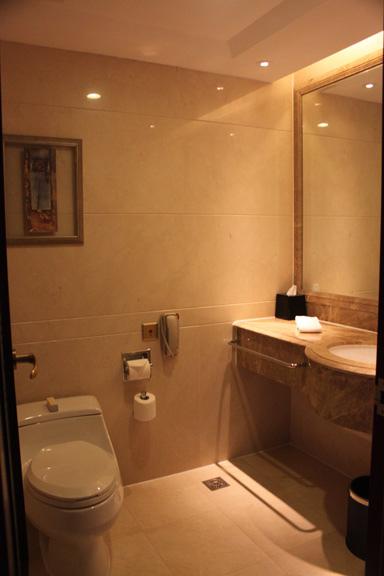How many flowers are in the bathroom?
Answer briefly. 0. Where is the toilet's flush bar?
Answer briefly. On top. Is the lid up?
Be succinct. No. Is their toilet paper on the holder?
Concise answer only. Yes. What color is the waste basket?
Be succinct. Black. Where is the sink?
Give a very brief answer. On right. What color is the toilet?
Concise answer only. White. Is the toilet lid down?
Write a very short answer. Yes. What's unusual about this set up?
Short answer required. Nothing. What is sitting on the sink?
Quick response, please. Nothing. 